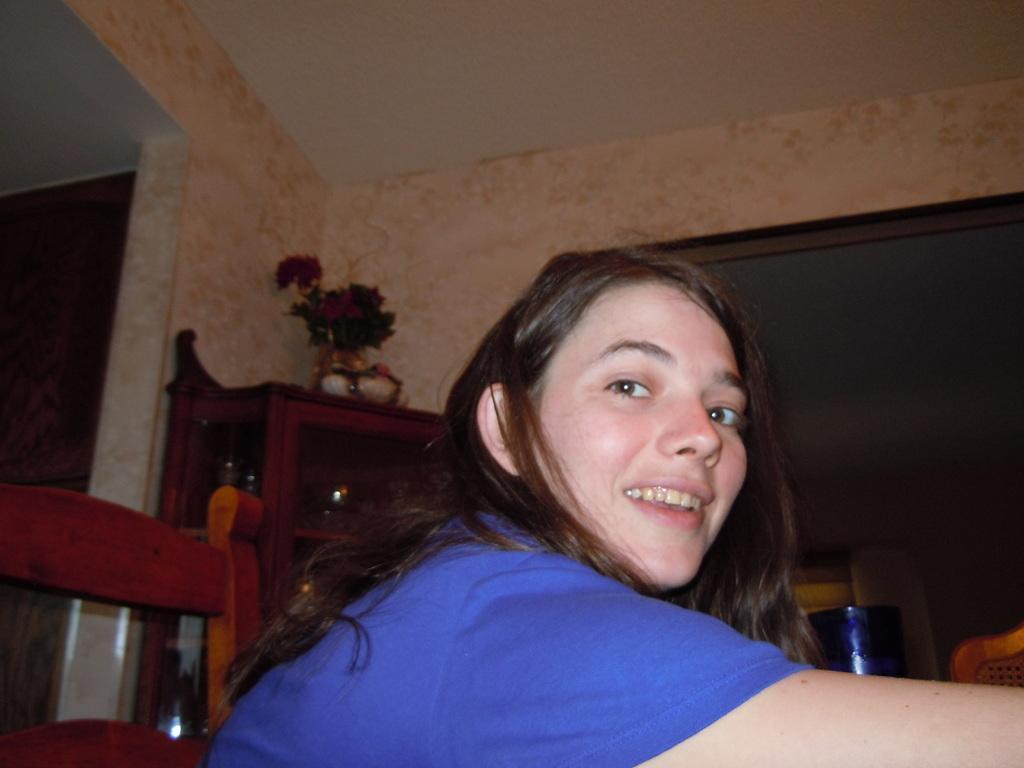Who is present in the image? There is a woman in the image. What is the woman doing in the image? The woman is looking at a camera and smiling. What can be seen in the background of the image? There is a chair and a flower showpiece in the image. What type of trade is being conducted in the image? There is no trade being conducted in the image; it features a woman looking at a camera and smiling. What color is the sweater the woman is wearing in the image? The provided facts do not mention a sweater, so we cannot determine the color of a sweater in the image. 